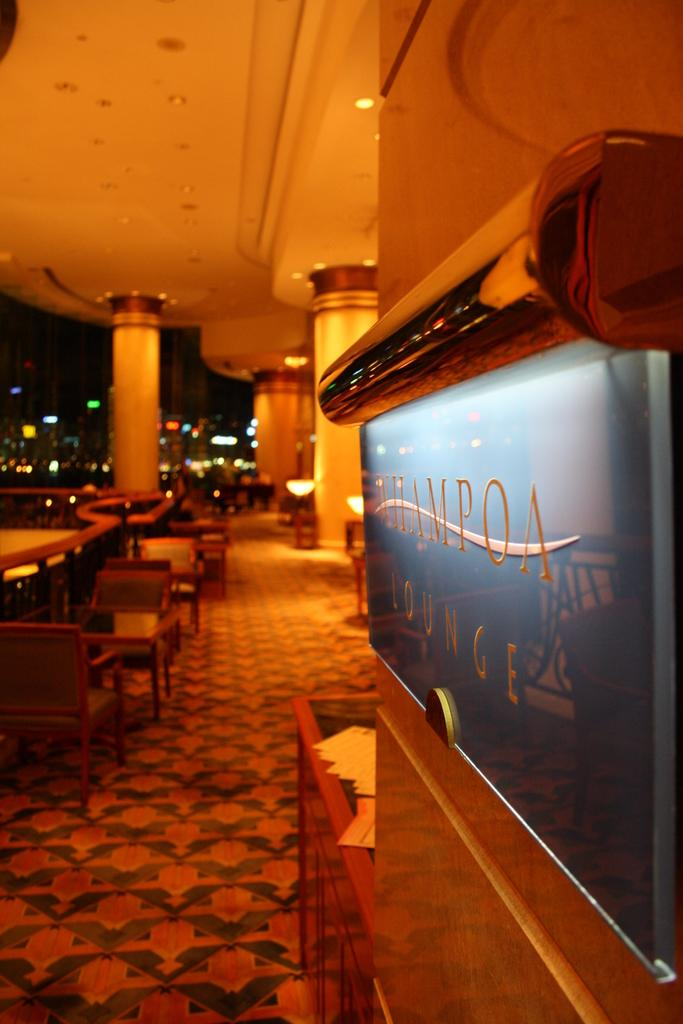What is on the wall in the foreground of the image? There is a board on the wall in the foreground of the image. What architectural features can be seen in the background of the image? There are pillars, a ceiling, chairs, tables, and a railing visible in the background of the image. What part of the room is visible in the background of the image? The floor is visible in the background of the image. Can you see any flowers or birds in the image? There are no flowers or birds present in the image. 